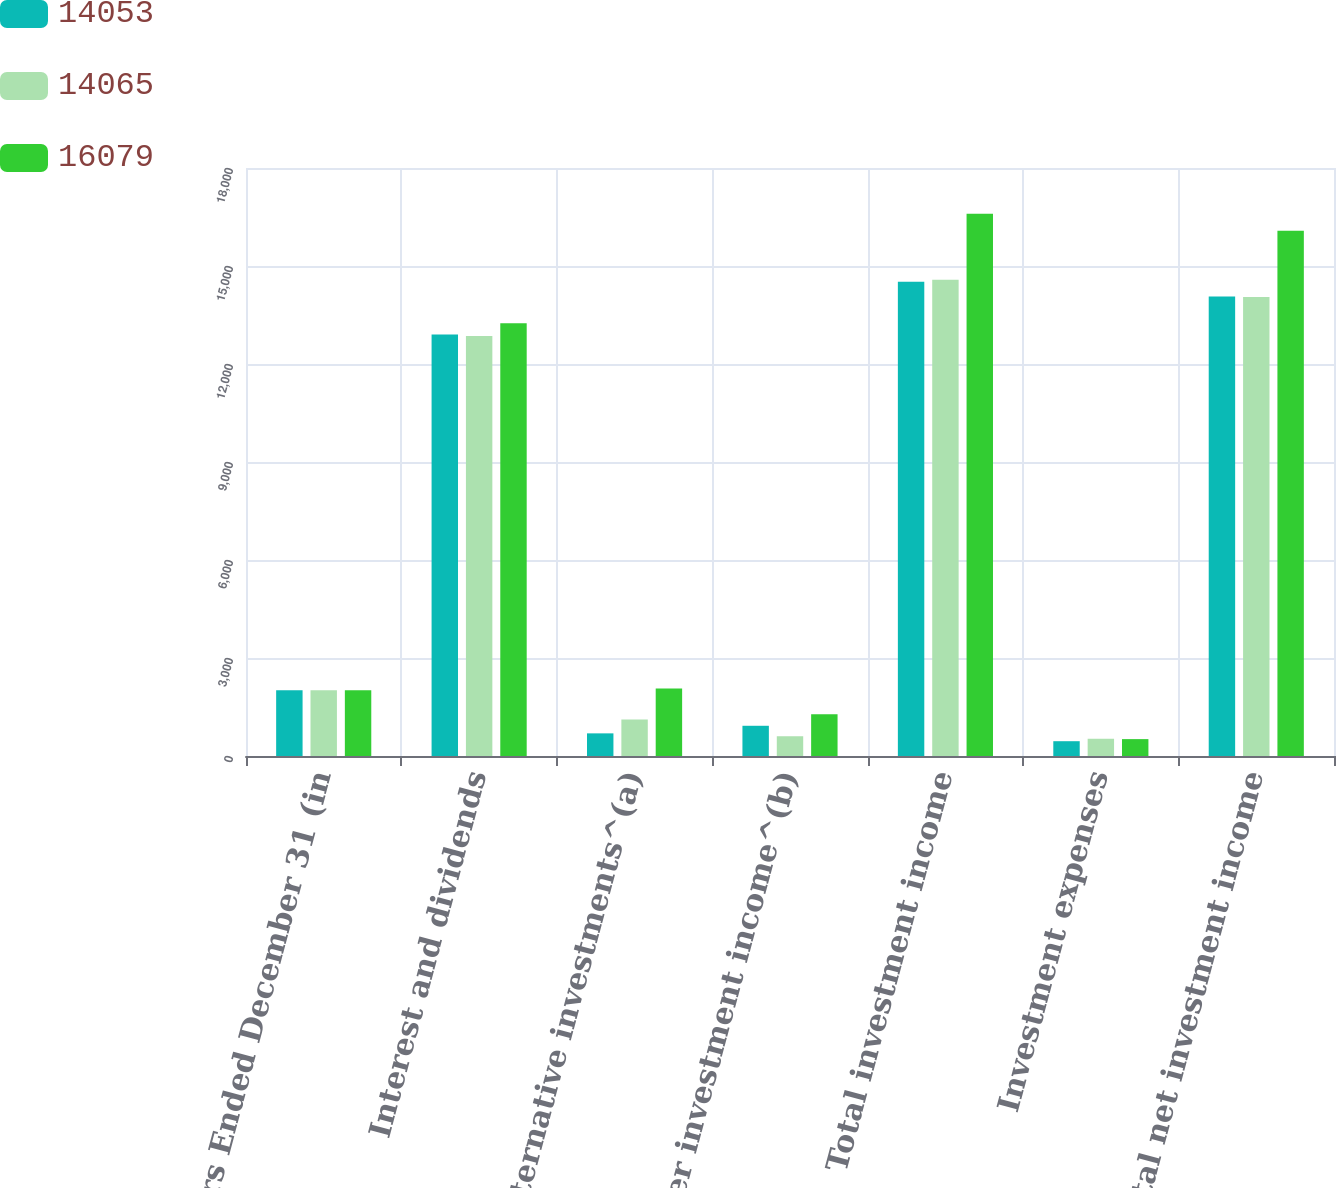<chart> <loc_0><loc_0><loc_500><loc_500><stacked_bar_chart><ecel><fcel>Years Ended December 31 (in<fcel>Interest and dividends<fcel>Alternative investments^(a)<fcel>Other investment income^(b)<fcel>Total investment income<fcel>Investment expenses<fcel>Total net investment income<nl><fcel>14053<fcel>2016<fcel>12900<fcel>693<fcel>925<fcel>14518<fcel>453<fcel>14065<nl><fcel>14065<fcel>2015<fcel>12856<fcel>1120<fcel>605<fcel>14581<fcel>528<fcel>14053<nl><fcel>16079<fcel>2014<fcel>13246<fcel>2070<fcel>1280<fcel>16596<fcel>517<fcel>16079<nl></chart> 